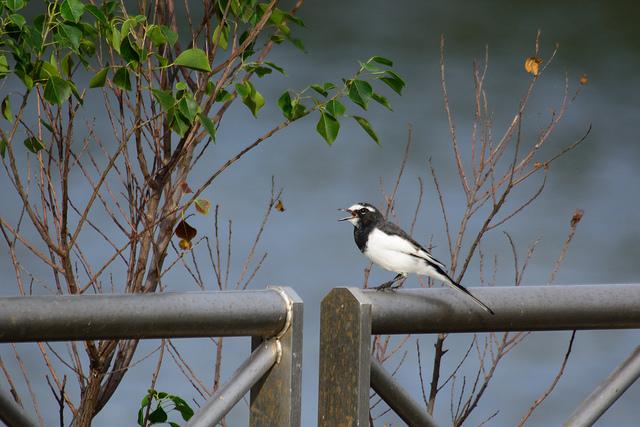What are the birds sitting on?
Short answer required. Fence. How many birds are in the picture?
Answer briefly. 1. What color is the bird?
Be succinct. Black and white. What is the bird sitting on?
Concise answer only. Fence. What are they perched upon?
Give a very brief answer. Fence. What is the bird standing on?
Give a very brief answer. Fence. What color object is the bird standing on?
Give a very brief answer. Gray. 